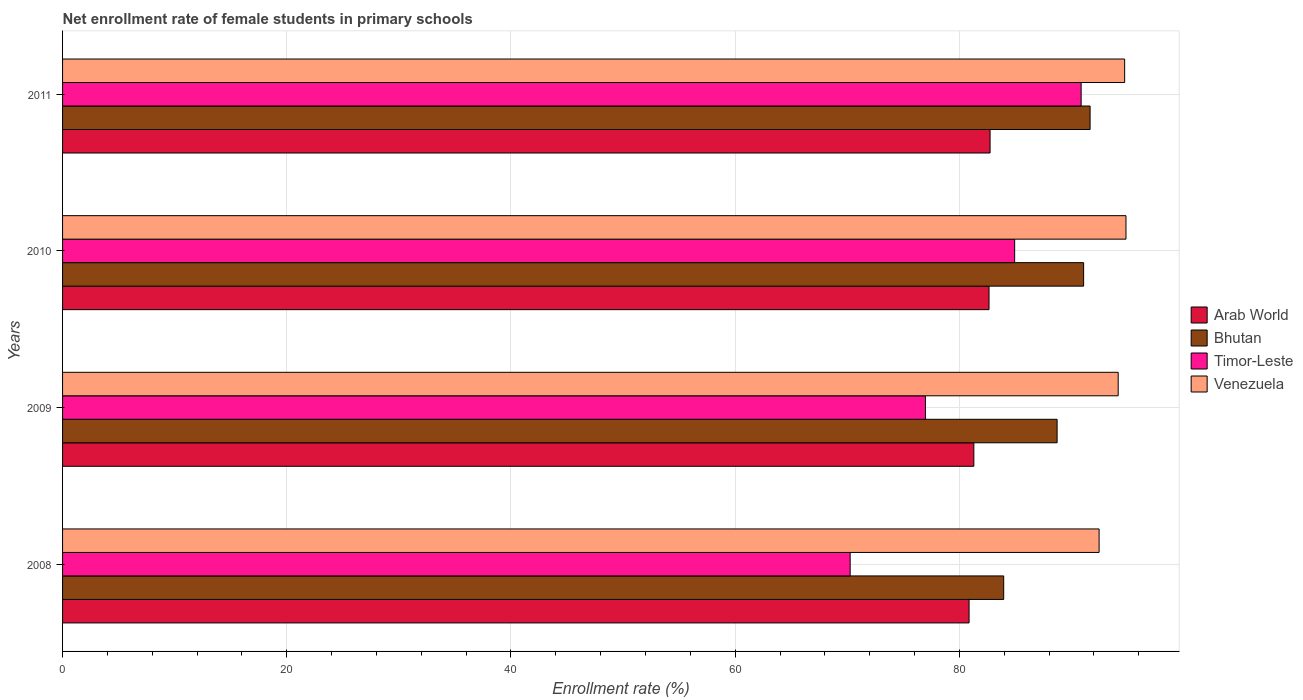Are the number of bars per tick equal to the number of legend labels?
Offer a terse response. Yes. Are the number of bars on each tick of the Y-axis equal?
Keep it short and to the point. Yes. How many bars are there on the 3rd tick from the bottom?
Provide a succinct answer. 4. What is the label of the 1st group of bars from the top?
Offer a very short reply. 2011. What is the net enrollment rate of female students in primary schools in Venezuela in 2008?
Provide a short and direct response. 92.47. Across all years, what is the maximum net enrollment rate of female students in primary schools in Arab World?
Keep it short and to the point. 82.74. Across all years, what is the minimum net enrollment rate of female students in primary schools in Bhutan?
Provide a succinct answer. 83.95. In which year was the net enrollment rate of female students in primary schools in Arab World maximum?
Your response must be concise. 2011. What is the total net enrollment rate of female students in primary schools in Bhutan in the graph?
Provide a succinct answer. 355.42. What is the difference between the net enrollment rate of female students in primary schools in Bhutan in 2008 and that in 2010?
Ensure brevity in your answer.  -7.13. What is the difference between the net enrollment rate of female students in primary schools in Arab World in 2010 and the net enrollment rate of female students in primary schools in Venezuela in 2008?
Offer a very short reply. -9.82. What is the average net enrollment rate of female students in primary schools in Timor-Leste per year?
Ensure brevity in your answer.  80.76. In the year 2008, what is the difference between the net enrollment rate of female students in primary schools in Timor-Leste and net enrollment rate of female students in primary schools in Arab World?
Provide a succinct answer. -10.61. In how many years, is the net enrollment rate of female students in primary schools in Arab World greater than 84 %?
Your response must be concise. 0. What is the ratio of the net enrollment rate of female students in primary schools in Timor-Leste in 2009 to that in 2011?
Provide a succinct answer. 0.85. Is the net enrollment rate of female students in primary schools in Timor-Leste in 2008 less than that in 2010?
Keep it short and to the point. Yes. Is the difference between the net enrollment rate of female students in primary schools in Timor-Leste in 2009 and 2011 greater than the difference between the net enrollment rate of female students in primary schools in Arab World in 2009 and 2011?
Your response must be concise. No. What is the difference between the highest and the second highest net enrollment rate of female students in primary schools in Venezuela?
Make the answer very short. 0.12. What is the difference between the highest and the lowest net enrollment rate of female students in primary schools in Timor-Leste?
Make the answer very short. 20.61. In how many years, is the net enrollment rate of female students in primary schools in Bhutan greater than the average net enrollment rate of female students in primary schools in Bhutan taken over all years?
Your answer should be compact. 2. Is the sum of the net enrollment rate of female students in primary schools in Timor-Leste in 2008 and 2009 greater than the maximum net enrollment rate of female students in primary schools in Arab World across all years?
Your answer should be compact. Yes. What does the 1st bar from the top in 2009 represents?
Your answer should be compact. Venezuela. What does the 1st bar from the bottom in 2008 represents?
Keep it short and to the point. Arab World. How many bars are there?
Ensure brevity in your answer.  16. How many years are there in the graph?
Your answer should be very brief. 4. Does the graph contain any zero values?
Make the answer very short. No. Where does the legend appear in the graph?
Keep it short and to the point. Center right. How many legend labels are there?
Keep it short and to the point. 4. How are the legend labels stacked?
Provide a succinct answer. Vertical. What is the title of the graph?
Offer a very short reply. Net enrollment rate of female students in primary schools. What is the label or title of the X-axis?
Your answer should be very brief. Enrollment rate (%). What is the Enrollment rate (%) in Arab World in 2008?
Give a very brief answer. 80.87. What is the Enrollment rate (%) in Bhutan in 2008?
Offer a terse response. 83.95. What is the Enrollment rate (%) of Timor-Leste in 2008?
Your answer should be compact. 70.26. What is the Enrollment rate (%) of Venezuela in 2008?
Offer a very short reply. 92.47. What is the Enrollment rate (%) of Arab World in 2009?
Keep it short and to the point. 81.29. What is the Enrollment rate (%) of Bhutan in 2009?
Provide a succinct answer. 88.72. What is the Enrollment rate (%) in Timor-Leste in 2009?
Keep it short and to the point. 76.97. What is the Enrollment rate (%) in Venezuela in 2009?
Offer a very short reply. 94.17. What is the Enrollment rate (%) of Arab World in 2010?
Provide a short and direct response. 82.65. What is the Enrollment rate (%) in Bhutan in 2010?
Give a very brief answer. 91.09. What is the Enrollment rate (%) of Timor-Leste in 2010?
Give a very brief answer. 84.93. What is the Enrollment rate (%) of Venezuela in 2010?
Your answer should be very brief. 94.86. What is the Enrollment rate (%) in Arab World in 2011?
Make the answer very short. 82.74. What is the Enrollment rate (%) of Bhutan in 2011?
Provide a succinct answer. 91.66. What is the Enrollment rate (%) of Timor-Leste in 2011?
Keep it short and to the point. 90.86. What is the Enrollment rate (%) of Venezuela in 2011?
Provide a succinct answer. 94.74. Across all years, what is the maximum Enrollment rate (%) of Arab World?
Offer a terse response. 82.74. Across all years, what is the maximum Enrollment rate (%) in Bhutan?
Your answer should be compact. 91.66. Across all years, what is the maximum Enrollment rate (%) of Timor-Leste?
Keep it short and to the point. 90.86. Across all years, what is the maximum Enrollment rate (%) of Venezuela?
Offer a very short reply. 94.86. Across all years, what is the minimum Enrollment rate (%) in Arab World?
Make the answer very short. 80.87. Across all years, what is the minimum Enrollment rate (%) of Bhutan?
Ensure brevity in your answer.  83.95. Across all years, what is the minimum Enrollment rate (%) in Timor-Leste?
Your answer should be very brief. 70.26. Across all years, what is the minimum Enrollment rate (%) in Venezuela?
Keep it short and to the point. 92.47. What is the total Enrollment rate (%) of Arab World in the graph?
Offer a terse response. 327.55. What is the total Enrollment rate (%) of Bhutan in the graph?
Keep it short and to the point. 355.42. What is the total Enrollment rate (%) of Timor-Leste in the graph?
Offer a very short reply. 323.03. What is the total Enrollment rate (%) of Venezuela in the graph?
Your answer should be compact. 376.24. What is the difference between the Enrollment rate (%) of Arab World in 2008 and that in 2009?
Provide a short and direct response. -0.42. What is the difference between the Enrollment rate (%) in Bhutan in 2008 and that in 2009?
Provide a succinct answer. -4.76. What is the difference between the Enrollment rate (%) in Timor-Leste in 2008 and that in 2009?
Provide a short and direct response. -6.71. What is the difference between the Enrollment rate (%) in Venezuela in 2008 and that in 2009?
Make the answer very short. -1.7. What is the difference between the Enrollment rate (%) of Arab World in 2008 and that in 2010?
Your answer should be compact. -1.78. What is the difference between the Enrollment rate (%) of Bhutan in 2008 and that in 2010?
Make the answer very short. -7.13. What is the difference between the Enrollment rate (%) in Timor-Leste in 2008 and that in 2010?
Make the answer very short. -14.67. What is the difference between the Enrollment rate (%) of Venezuela in 2008 and that in 2010?
Offer a terse response. -2.4. What is the difference between the Enrollment rate (%) in Arab World in 2008 and that in 2011?
Ensure brevity in your answer.  -1.87. What is the difference between the Enrollment rate (%) of Bhutan in 2008 and that in 2011?
Provide a short and direct response. -7.71. What is the difference between the Enrollment rate (%) in Timor-Leste in 2008 and that in 2011?
Ensure brevity in your answer.  -20.61. What is the difference between the Enrollment rate (%) in Venezuela in 2008 and that in 2011?
Your response must be concise. -2.28. What is the difference between the Enrollment rate (%) of Arab World in 2009 and that in 2010?
Keep it short and to the point. -1.35. What is the difference between the Enrollment rate (%) in Bhutan in 2009 and that in 2010?
Your answer should be very brief. -2.37. What is the difference between the Enrollment rate (%) in Timor-Leste in 2009 and that in 2010?
Keep it short and to the point. -7.96. What is the difference between the Enrollment rate (%) in Venezuela in 2009 and that in 2010?
Ensure brevity in your answer.  -0.7. What is the difference between the Enrollment rate (%) in Arab World in 2009 and that in 2011?
Offer a very short reply. -1.45. What is the difference between the Enrollment rate (%) of Bhutan in 2009 and that in 2011?
Offer a terse response. -2.94. What is the difference between the Enrollment rate (%) in Timor-Leste in 2009 and that in 2011?
Your answer should be compact. -13.89. What is the difference between the Enrollment rate (%) of Venezuela in 2009 and that in 2011?
Keep it short and to the point. -0.58. What is the difference between the Enrollment rate (%) of Arab World in 2010 and that in 2011?
Your answer should be very brief. -0.09. What is the difference between the Enrollment rate (%) in Bhutan in 2010 and that in 2011?
Keep it short and to the point. -0.58. What is the difference between the Enrollment rate (%) of Timor-Leste in 2010 and that in 2011?
Provide a succinct answer. -5.93. What is the difference between the Enrollment rate (%) of Venezuela in 2010 and that in 2011?
Offer a very short reply. 0.12. What is the difference between the Enrollment rate (%) in Arab World in 2008 and the Enrollment rate (%) in Bhutan in 2009?
Make the answer very short. -7.85. What is the difference between the Enrollment rate (%) of Arab World in 2008 and the Enrollment rate (%) of Timor-Leste in 2009?
Your response must be concise. 3.89. What is the difference between the Enrollment rate (%) of Arab World in 2008 and the Enrollment rate (%) of Venezuela in 2009?
Your response must be concise. -13.3. What is the difference between the Enrollment rate (%) in Bhutan in 2008 and the Enrollment rate (%) in Timor-Leste in 2009?
Make the answer very short. 6.98. What is the difference between the Enrollment rate (%) of Bhutan in 2008 and the Enrollment rate (%) of Venezuela in 2009?
Make the answer very short. -10.21. What is the difference between the Enrollment rate (%) in Timor-Leste in 2008 and the Enrollment rate (%) in Venezuela in 2009?
Your answer should be very brief. -23.91. What is the difference between the Enrollment rate (%) in Arab World in 2008 and the Enrollment rate (%) in Bhutan in 2010?
Offer a terse response. -10.22. What is the difference between the Enrollment rate (%) in Arab World in 2008 and the Enrollment rate (%) in Timor-Leste in 2010?
Your answer should be very brief. -4.07. What is the difference between the Enrollment rate (%) in Arab World in 2008 and the Enrollment rate (%) in Venezuela in 2010?
Your answer should be very brief. -14. What is the difference between the Enrollment rate (%) of Bhutan in 2008 and the Enrollment rate (%) of Timor-Leste in 2010?
Your answer should be compact. -0.98. What is the difference between the Enrollment rate (%) of Bhutan in 2008 and the Enrollment rate (%) of Venezuela in 2010?
Your response must be concise. -10.91. What is the difference between the Enrollment rate (%) of Timor-Leste in 2008 and the Enrollment rate (%) of Venezuela in 2010?
Your response must be concise. -24.6. What is the difference between the Enrollment rate (%) of Arab World in 2008 and the Enrollment rate (%) of Bhutan in 2011?
Ensure brevity in your answer.  -10.8. What is the difference between the Enrollment rate (%) of Arab World in 2008 and the Enrollment rate (%) of Timor-Leste in 2011?
Your response must be concise. -10. What is the difference between the Enrollment rate (%) in Arab World in 2008 and the Enrollment rate (%) in Venezuela in 2011?
Provide a succinct answer. -13.88. What is the difference between the Enrollment rate (%) of Bhutan in 2008 and the Enrollment rate (%) of Timor-Leste in 2011?
Your response must be concise. -6.91. What is the difference between the Enrollment rate (%) of Bhutan in 2008 and the Enrollment rate (%) of Venezuela in 2011?
Provide a succinct answer. -10.79. What is the difference between the Enrollment rate (%) of Timor-Leste in 2008 and the Enrollment rate (%) of Venezuela in 2011?
Offer a terse response. -24.49. What is the difference between the Enrollment rate (%) of Arab World in 2009 and the Enrollment rate (%) of Bhutan in 2010?
Give a very brief answer. -9.79. What is the difference between the Enrollment rate (%) of Arab World in 2009 and the Enrollment rate (%) of Timor-Leste in 2010?
Keep it short and to the point. -3.64. What is the difference between the Enrollment rate (%) in Arab World in 2009 and the Enrollment rate (%) in Venezuela in 2010?
Your answer should be very brief. -13.57. What is the difference between the Enrollment rate (%) in Bhutan in 2009 and the Enrollment rate (%) in Timor-Leste in 2010?
Make the answer very short. 3.79. What is the difference between the Enrollment rate (%) in Bhutan in 2009 and the Enrollment rate (%) in Venezuela in 2010?
Offer a terse response. -6.14. What is the difference between the Enrollment rate (%) of Timor-Leste in 2009 and the Enrollment rate (%) of Venezuela in 2010?
Keep it short and to the point. -17.89. What is the difference between the Enrollment rate (%) of Arab World in 2009 and the Enrollment rate (%) of Bhutan in 2011?
Your response must be concise. -10.37. What is the difference between the Enrollment rate (%) of Arab World in 2009 and the Enrollment rate (%) of Timor-Leste in 2011?
Provide a short and direct response. -9.57. What is the difference between the Enrollment rate (%) of Arab World in 2009 and the Enrollment rate (%) of Venezuela in 2011?
Offer a very short reply. -13.45. What is the difference between the Enrollment rate (%) in Bhutan in 2009 and the Enrollment rate (%) in Timor-Leste in 2011?
Offer a very short reply. -2.14. What is the difference between the Enrollment rate (%) in Bhutan in 2009 and the Enrollment rate (%) in Venezuela in 2011?
Ensure brevity in your answer.  -6.03. What is the difference between the Enrollment rate (%) of Timor-Leste in 2009 and the Enrollment rate (%) of Venezuela in 2011?
Your response must be concise. -17.77. What is the difference between the Enrollment rate (%) of Arab World in 2010 and the Enrollment rate (%) of Bhutan in 2011?
Keep it short and to the point. -9.02. What is the difference between the Enrollment rate (%) of Arab World in 2010 and the Enrollment rate (%) of Timor-Leste in 2011?
Your answer should be very brief. -8.22. What is the difference between the Enrollment rate (%) of Arab World in 2010 and the Enrollment rate (%) of Venezuela in 2011?
Offer a terse response. -12.1. What is the difference between the Enrollment rate (%) in Bhutan in 2010 and the Enrollment rate (%) in Timor-Leste in 2011?
Keep it short and to the point. 0.22. What is the difference between the Enrollment rate (%) of Bhutan in 2010 and the Enrollment rate (%) of Venezuela in 2011?
Ensure brevity in your answer.  -3.66. What is the difference between the Enrollment rate (%) in Timor-Leste in 2010 and the Enrollment rate (%) in Venezuela in 2011?
Offer a terse response. -9.81. What is the average Enrollment rate (%) in Arab World per year?
Your answer should be very brief. 81.89. What is the average Enrollment rate (%) in Bhutan per year?
Keep it short and to the point. 88.86. What is the average Enrollment rate (%) in Timor-Leste per year?
Your response must be concise. 80.76. What is the average Enrollment rate (%) of Venezuela per year?
Provide a short and direct response. 94.06. In the year 2008, what is the difference between the Enrollment rate (%) of Arab World and Enrollment rate (%) of Bhutan?
Keep it short and to the point. -3.09. In the year 2008, what is the difference between the Enrollment rate (%) in Arab World and Enrollment rate (%) in Timor-Leste?
Make the answer very short. 10.61. In the year 2008, what is the difference between the Enrollment rate (%) in Arab World and Enrollment rate (%) in Venezuela?
Provide a succinct answer. -11.6. In the year 2008, what is the difference between the Enrollment rate (%) of Bhutan and Enrollment rate (%) of Timor-Leste?
Your response must be concise. 13.7. In the year 2008, what is the difference between the Enrollment rate (%) of Bhutan and Enrollment rate (%) of Venezuela?
Give a very brief answer. -8.51. In the year 2008, what is the difference between the Enrollment rate (%) of Timor-Leste and Enrollment rate (%) of Venezuela?
Your answer should be compact. -22.21. In the year 2009, what is the difference between the Enrollment rate (%) in Arab World and Enrollment rate (%) in Bhutan?
Your answer should be very brief. -7.43. In the year 2009, what is the difference between the Enrollment rate (%) of Arab World and Enrollment rate (%) of Timor-Leste?
Offer a terse response. 4.32. In the year 2009, what is the difference between the Enrollment rate (%) in Arab World and Enrollment rate (%) in Venezuela?
Give a very brief answer. -12.88. In the year 2009, what is the difference between the Enrollment rate (%) of Bhutan and Enrollment rate (%) of Timor-Leste?
Your answer should be compact. 11.75. In the year 2009, what is the difference between the Enrollment rate (%) in Bhutan and Enrollment rate (%) in Venezuela?
Offer a very short reply. -5.45. In the year 2009, what is the difference between the Enrollment rate (%) of Timor-Leste and Enrollment rate (%) of Venezuela?
Offer a very short reply. -17.2. In the year 2010, what is the difference between the Enrollment rate (%) of Arab World and Enrollment rate (%) of Bhutan?
Offer a terse response. -8.44. In the year 2010, what is the difference between the Enrollment rate (%) of Arab World and Enrollment rate (%) of Timor-Leste?
Ensure brevity in your answer.  -2.29. In the year 2010, what is the difference between the Enrollment rate (%) in Arab World and Enrollment rate (%) in Venezuela?
Make the answer very short. -12.22. In the year 2010, what is the difference between the Enrollment rate (%) in Bhutan and Enrollment rate (%) in Timor-Leste?
Offer a terse response. 6.15. In the year 2010, what is the difference between the Enrollment rate (%) in Bhutan and Enrollment rate (%) in Venezuela?
Your answer should be very brief. -3.78. In the year 2010, what is the difference between the Enrollment rate (%) in Timor-Leste and Enrollment rate (%) in Venezuela?
Your response must be concise. -9.93. In the year 2011, what is the difference between the Enrollment rate (%) of Arab World and Enrollment rate (%) of Bhutan?
Offer a very short reply. -8.92. In the year 2011, what is the difference between the Enrollment rate (%) in Arab World and Enrollment rate (%) in Timor-Leste?
Provide a succinct answer. -8.12. In the year 2011, what is the difference between the Enrollment rate (%) in Arab World and Enrollment rate (%) in Venezuela?
Your answer should be very brief. -12. In the year 2011, what is the difference between the Enrollment rate (%) in Bhutan and Enrollment rate (%) in Timor-Leste?
Keep it short and to the point. 0.8. In the year 2011, what is the difference between the Enrollment rate (%) in Bhutan and Enrollment rate (%) in Venezuela?
Your answer should be very brief. -3.08. In the year 2011, what is the difference between the Enrollment rate (%) of Timor-Leste and Enrollment rate (%) of Venezuela?
Your answer should be very brief. -3.88. What is the ratio of the Enrollment rate (%) of Arab World in 2008 to that in 2009?
Give a very brief answer. 0.99. What is the ratio of the Enrollment rate (%) of Bhutan in 2008 to that in 2009?
Your answer should be very brief. 0.95. What is the ratio of the Enrollment rate (%) in Timor-Leste in 2008 to that in 2009?
Your answer should be compact. 0.91. What is the ratio of the Enrollment rate (%) in Venezuela in 2008 to that in 2009?
Offer a terse response. 0.98. What is the ratio of the Enrollment rate (%) of Arab World in 2008 to that in 2010?
Ensure brevity in your answer.  0.98. What is the ratio of the Enrollment rate (%) of Bhutan in 2008 to that in 2010?
Provide a short and direct response. 0.92. What is the ratio of the Enrollment rate (%) of Timor-Leste in 2008 to that in 2010?
Offer a very short reply. 0.83. What is the ratio of the Enrollment rate (%) in Venezuela in 2008 to that in 2010?
Your answer should be compact. 0.97. What is the ratio of the Enrollment rate (%) of Arab World in 2008 to that in 2011?
Your answer should be compact. 0.98. What is the ratio of the Enrollment rate (%) of Bhutan in 2008 to that in 2011?
Give a very brief answer. 0.92. What is the ratio of the Enrollment rate (%) in Timor-Leste in 2008 to that in 2011?
Make the answer very short. 0.77. What is the ratio of the Enrollment rate (%) of Arab World in 2009 to that in 2010?
Provide a succinct answer. 0.98. What is the ratio of the Enrollment rate (%) in Bhutan in 2009 to that in 2010?
Your response must be concise. 0.97. What is the ratio of the Enrollment rate (%) of Timor-Leste in 2009 to that in 2010?
Your answer should be very brief. 0.91. What is the ratio of the Enrollment rate (%) of Venezuela in 2009 to that in 2010?
Ensure brevity in your answer.  0.99. What is the ratio of the Enrollment rate (%) of Arab World in 2009 to that in 2011?
Your answer should be very brief. 0.98. What is the ratio of the Enrollment rate (%) of Bhutan in 2009 to that in 2011?
Keep it short and to the point. 0.97. What is the ratio of the Enrollment rate (%) in Timor-Leste in 2009 to that in 2011?
Provide a succinct answer. 0.85. What is the ratio of the Enrollment rate (%) of Arab World in 2010 to that in 2011?
Provide a succinct answer. 1. What is the ratio of the Enrollment rate (%) of Timor-Leste in 2010 to that in 2011?
Your answer should be compact. 0.93. What is the ratio of the Enrollment rate (%) of Venezuela in 2010 to that in 2011?
Keep it short and to the point. 1. What is the difference between the highest and the second highest Enrollment rate (%) in Arab World?
Make the answer very short. 0.09. What is the difference between the highest and the second highest Enrollment rate (%) of Bhutan?
Keep it short and to the point. 0.58. What is the difference between the highest and the second highest Enrollment rate (%) of Timor-Leste?
Offer a terse response. 5.93. What is the difference between the highest and the second highest Enrollment rate (%) of Venezuela?
Your answer should be compact. 0.12. What is the difference between the highest and the lowest Enrollment rate (%) of Arab World?
Ensure brevity in your answer.  1.87. What is the difference between the highest and the lowest Enrollment rate (%) of Bhutan?
Give a very brief answer. 7.71. What is the difference between the highest and the lowest Enrollment rate (%) of Timor-Leste?
Ensure brevity in your answer.  20.61. What is the difference between the highest and the lowest Enrollment rate (%) in Venezuela?
Your answer should be compact. 2.4. 